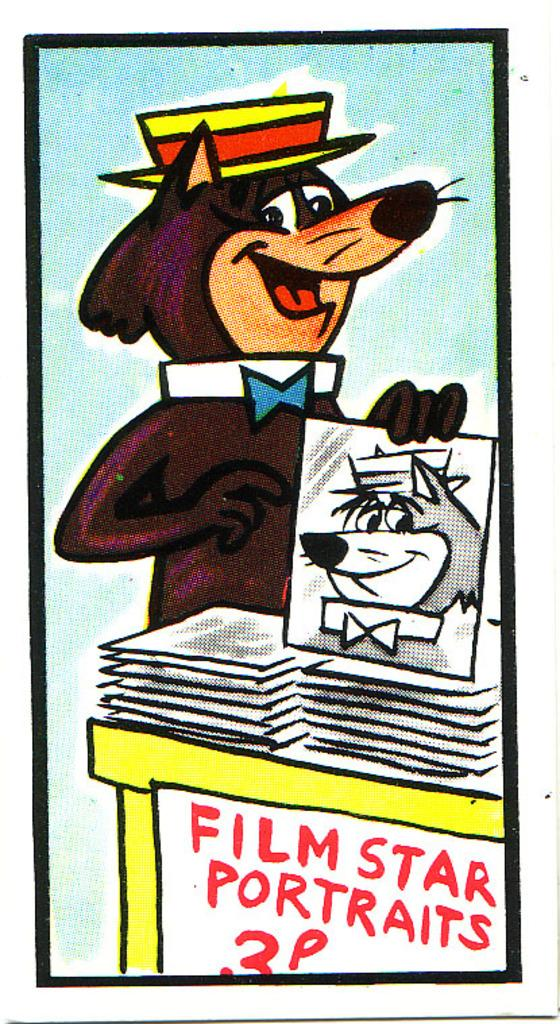<image>
Offer a succinct explanation of the picture presented. A human like animal selling portraits of film stars at a yellow table. 